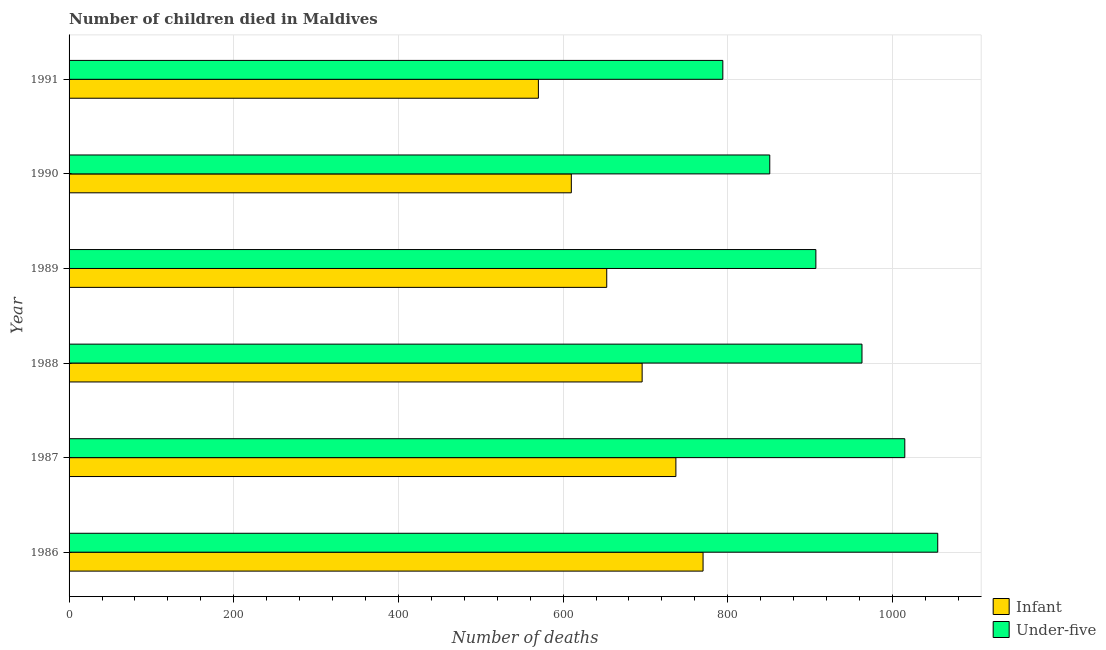How many groups of bars are there?
Your response must be concise. 6. Are the number of bars per tick equal to the number of legend labels?
Your response must be concise. Yes. What is the label of the 2nd group of bars from the top?
Your answer should be very brief. 1990. In how many cases, is the number of bars for a given year not equal to the number of legend labels?
Make the answer very short. 0. What is the number of under-five deaths in 1989?
Your answer should be compact. 907. Across all years, what is the maximum number of under-five deaths?
Offer a very short reply. 1055. Across all years, what is the minimum number of under-five deaths?
Offer a very short reply. 794. In which year was the number of infant deaths maximum?
Provide a short and direct response. 1986. In which year was the number of under-five deaths minimum?
Your response must be concise. 1991. What is the total number of infant deaths in the graph?
Offer a very short reply. 4036. What is the difference between the number of under-five deaths in 1989 and that in 1991?
Provide a succinct answer. 113. What is the difference between the number of infant deaths in 1989 and the number of under-five deaths in 1986?
Ensure brevity in your answer.  -402. What is the average number of under-five deaths per year?
Provide a short and direct response. 930.83. In the year 1987, what is the difference between the number of infant deaths and number of under-five deaths?
Your response must be concise. -278. What is the ratio of the number of infant deaths in 1986 to that in 1988?
Provide a short and direct response. 1.11. Is the number of under-five deaths in 1986 less than that in 1991?
Your response must be concise. No. Is the difference between the number of under-five deaths in 1990 and 1991 greater than the difference between the number of infant deaths in 1990 and 1991?
Ensure brevity in your answer.  Yes. What is the difference between the highest and the second highest number of under-five deaths?
Offer a very short reply. 40. What is the difference between the highest and the lowest number of under-five deaths?
Your answer should be very brief. 261. Is the sum of the number of infant deaths in 1988 and 1991 greater than the maximum number of under-five deaths across all years?
Offer a very short reply. Yes. What does the 1st bar from the top in 1991 represents?
Offer a terse response. Under-five. What does the 1st bar from the bottom in 1989 represents?
Keep it short and to the point. Infant. How many years are there in the graph?
Your response must be concise. 6. Are the values on the major ticks of X-axis written in scientific E-notation?
Your answer should be very brief. No. Does the graph contain grids?
Your response must be concise. Yes. What is the title of the graph?
Ensure brevity in your answer.  Number of children died in Maldives. What is the label or title of the X-axis?
Offer a terse response. Number of deaths. What is the Number of deaths in Infant in 1986?
Give a very brief answer. 770. What is the Number of deaths in Under-five in 1986?
Ensure brevity in your answer.  1055. What is the Number of deaths of Infant in 1987?
Keep it short and to the point. 737. What is the Number of deaths in Under-five in 1987?
Ensure brevity in your answer.  1015. What is the Number of deaths of Infant in 1988?
Your answer should be compact. 696. What is the Number of deaths in Under-five in 1988?
Your response must be concise. 963. What is the Number of deaths in Infant in 1989?
Offer a very short reply. 653. What is the Number of deaths in Under-five in 1989?
Offer a terse response. 907. What is the Number of deaths of Infant in 1990?
Offer a very short reply. 610. What is the Number of deaths of Under-five in 1990?
Your response must be concise. 851. What is the Number of deaths in Infant in 1991?
Your answer should be very brief. 570. What is the Number of deaths of Under-five in 1991?
Offer a very short reply. 794. Across all years, what is the maximum Number of deaths of Infant?
Give a very brief answer. 770. Across all years, what is the maximum Number of deaths of Under-five?
Keep it short and to the point. 1055. Across all years, what is the minimum Number of deaths of Infant?
Ensure brevity in your answer.  570. Across all years, what is the minimum Number of deaths of Under-five?
Make the answer very short. 794. What is the total Number of deaths in Infant in the graph?
Give a very brief answer. 4036. What is the total Number of deaths in Under-five in the graph?
Provide a succinct answer. 5585. What is the difference between the Number of deaths in Infant in 1986 and that in 1988?
Provide a succinct answer. 74. What is the difference between the Number of deaths of Under-five in 1986 and that in 1988?
Provide a short and direct response. 92. What is the difference between the Number of deaths in Infant in 1986 and that in 1989?
Offer a very short reply. 117. What is the difference between the Number of deaths of Under-five in 1986 and that in 1989?
Your answer should be compact. 148. What is the difference between the Number of deaths of Infant in 1986 and that in 1990?
Your answer should be very brief. 160. What is the difference between the Number of deaths of Under-five in 1986 and that in 1990?
Offer a terse response. 204. What is the difference between the Number of deaths in Under-five in 1986 and that in 1991?
Your answer should be very brief. 261. What is the difference between the Number of deaths in Infant in 1987 and that in 1988?
Keep it short and to the point. 41. What is the difference between the Number of deaths of Under-five in 1987 and that in 1988?
Give a very brief answer. 52. What is the difference between the Number of deaths in Under-five in 1987 and that in 1989?
Offer a very short reply. 108. What is the difference between the Number of deaths of Infant in 1987 and that in 1990?
Provide a succinct answer. 127. What is the difference between the Number of deaths in Under-five in 1987 and that in 1990?
Your response must be concise. 164. What is the difference between the Number of deaths in Infant in 1987 and that in 1991?
Offer a very short reply. 167. What is the difference between the Number of deaths of Under-five in 1987 and that in 1991?
Give a very brief answer. 221. What is the difference between the Number of deaths of Under-five in 1988 and that in 1989?
Make the answer very short. 56. What is the difference between the Number of deaths in Under-five in 1988 and that in 1990?
Offer a very short reply. 112. What is the difference between the Number of deaths of Infant in 1988 and that in 1991?
Your response must be concise. 126. What is the difference between the Number of deaths of Under-five in 1988 and that in 1991?
Give a very brief answer. 169. What is the difference between the Number of deaths of Under-five in 1989 and that in 1990?
Offer a terse response. 56. What is the difference between the Number of deaths of Under-five in 1989 and that in 1991?
Provide a succinct answer. 113. What is the difference between the Number of deaths of Infant in 1986 and the Number of deaths of Under-five in 1987?
Provide a short and direct response. -245. What is the difference between the Number of deaths in Infant in 1986 and the Number of deaths in Under-five in 1988?
Give a very brief answer. -193. What is the difference between the Number of deaths of Infant in 1986 and the Number of deaths of Under-five in 1989?
Keep it short and to the point. -137. What is the difference between the Number of deaths of Infant in 1986 and the Number of deaths of Under-five in 1990?
Make the answer very short. -81. What is the difference between the Number of deaths of Infant in 1986 and the Number of deaths of Under-five in 1991?
Offer a very short reply. -24. What is the difference between the Number of deaths of Infant in 1987 and the Number of deaths of Under-five in 1988?
Give a very brief answer. -226. What is the difference between the Number of deaths in Infant in 1987 and the Number of deaths in Under-five in 1989?
Provide a short and direct response. -170. What is the difference between the Number of deaths in Infant in 1987 and the Number of deaths in Under-five in 1990?
Make the answer very short. -114. What is the difference between the Number of deaths in Infant in 1987 and the Number of deaths in Under-five in 1991?
Your answer should be compact. -57. What is the difference between the Number of deaths of Infant in 1988 and the Number of deaths of Under-five in 1989?
Offer a terse response. -211. What is the difference between the Number of deaths of Infant in 1988 and the Number of deaths of Under-five in 1990?
Provide a succinct answer. -155. What is the difference between the Number of deaths in Infant in 1988 and the Number of deaths in Under-five in 1991?
Ensure brevity in your answer.  -98. What is the difference between the Number of deaths of Infant in 1989 and the Number of deaths of Under-five in 1990?
Your response must be concise. -198. What is the difference between the Number of deaths in Infant in 1989 and the Number of deaths in Under-five in 1991?
Provide a short and direct response. -141. What is the difference between the Number of deaths in Infant in 1990 and the Number of deaths in Under-five in 1991?
Ensure brevity in your answer.  -184. What is the average Number of deaths in Infant per year?
Offer a terse response. 672.67. What is the average Number of deaths of Under-five per year?
Offer a very short reply. 930.83. In the year 1986, what is the difference between the Number of deaths in Infant and Number of deaths in Under-five?
Provide a short and direct response. -285. In the year 1987, what is the difference between the Number of deaths in Infant and Number of deaths in Under-five?
Your answer should be compact. -278. In the year 1988, what is the difference between the Number of deaths of Infant and Number of deaths of Under-five?
Your answer should be compact. -267. In the year 1989, what is the difference between the Number of deaths of Infant and Number of deaths of Under-five?
Your answer should be very brief. -254. In the year 1990, what is the difference between the Number of deaths of Infant and Number of deaths of Under-five?
Your response must be concise. -241. In the year 1991, what is the difference between the Number of deaths in Infant and Number of deaths in Under-five?
Provide a succinct answer. -224. What is the ratio of the Number of deaths of Infant in 1986 to that in 1987?
Your answer should be compact. 1.04. What is the ratio of the Number of deaths of Under-five in 1986 to that in 1987?
Your answer should be compact. 1.04. What is the ratio of the Number of deaths in Infant in 1986 to that in 1988?
Provide a short and direct response. 1.11. What is the ratio of the Number of deaths in Under-five in 1986 to that in 1988?
Provide a succinct answer. 1.1. What is the ratio of the Number of deaths of Infant in 1986 to that in 1989?
Offer a very short reply. 1.18. What is the ratio of the Number of deaths of Under-five in 1986 to that in 1989?
Your answer should be compact. 1.16. What is the ratio of the Number of deaths of Infant in 1986 to that in 1990?
Make the answer very short. 1.26. What is the ratio of the Number of deaths of Under-five in 1986 to that in 1990?
Your response must be concise. 1.24. What is the ratio of the Number of deaths in Infant in 1986 to that in 1991?
Give a very brief answer. 1.35. What is the ratio of the Number of deaths of Under-five in 1986 to that in 1991?
Ensure brevity in your answer.  1.33. What is the ratio of the Number of deaths of Infant in 1987 to that in 1988?
Ensure brevity in your answer.  1.06. What is the ratio of the Number of deaths in Under-five in 1987 to that in 1988?
Make the answer very short. 1.05. What is the ratio of the Number of deaths in Infant in 1987 to that in 1989?
Make the answer very short. 1.13. What is the ratio of the Number of deaths of Under-five in 1987 to that in 1989?
Give a very brief answer. 1.12. What is the ratio of the Number of deaths in Infant in 1987 to that in 1990?
Offer a very short reply. 1.21. What is the ratio of the Number of deaths of Under-five in 1987 to that in 1990?
Give a very brief answer. 1.19. What is the ratio of the Number of deaths of Infant in 1987 to that in 1991?
Give a very brief answer. 1.29. What is the ratio of the Number of deaths in Under-five in 1987 to that in 1991?
Your answer should be very brief. 1.28. What is the ratio of the Number of deaths in Infant in 1988 to that in 1989?
Offer a very short reply. 1.07. What is the ratio of the Number of deaths in Under-five in 1988 to that in 1989?
Give a very brief answer. 1.06. What is the ratio of the Number of deaths of Infant in 1988 to that in 1990?
Ensure brevity in your answer.  1.14. What is the ratio of the Number of deaths in Under-five in 1988 to that in 1990?
Give a very brief answer. 1.13. What is the ratio of the Number of deaths in Infant in 1988 to that in 1991?
Offer a terse response. 1.22. What is the ratio of the Number of deaths of Under-five in 1988 to that in 1991?
Give a very brief answer. 1.21. What is the ratio of the Number of deaths of Infant in 1989 to that in 1990?
Your answer should be compact. 1.07. What is the ratio of the Number of deaths in Under-five in 1989 to that in 1990?
Offer a very short reply. 1.07. What is the ratio of the Number of deaths of Infant in 1989 to that in 1991?
Ensure brevity in your answer.  1.15. What is the ratio of the Number of deaths in Under-five in 1989 to that in 1991?
Your answer should be very brief. 1.14. What is the ratio of the Number of deaths in Infant in 1990 to that in 1991?
Provide a succinct answer. 1.07. What is the ratio of the Number of deaths in Under-five in 1990 to that in 1991?
Ensure brevity in your answer.  1.07. What is the difference between the highest and the lowest Number of deaths of Under-five?
Keep it short and to the point. 261. 